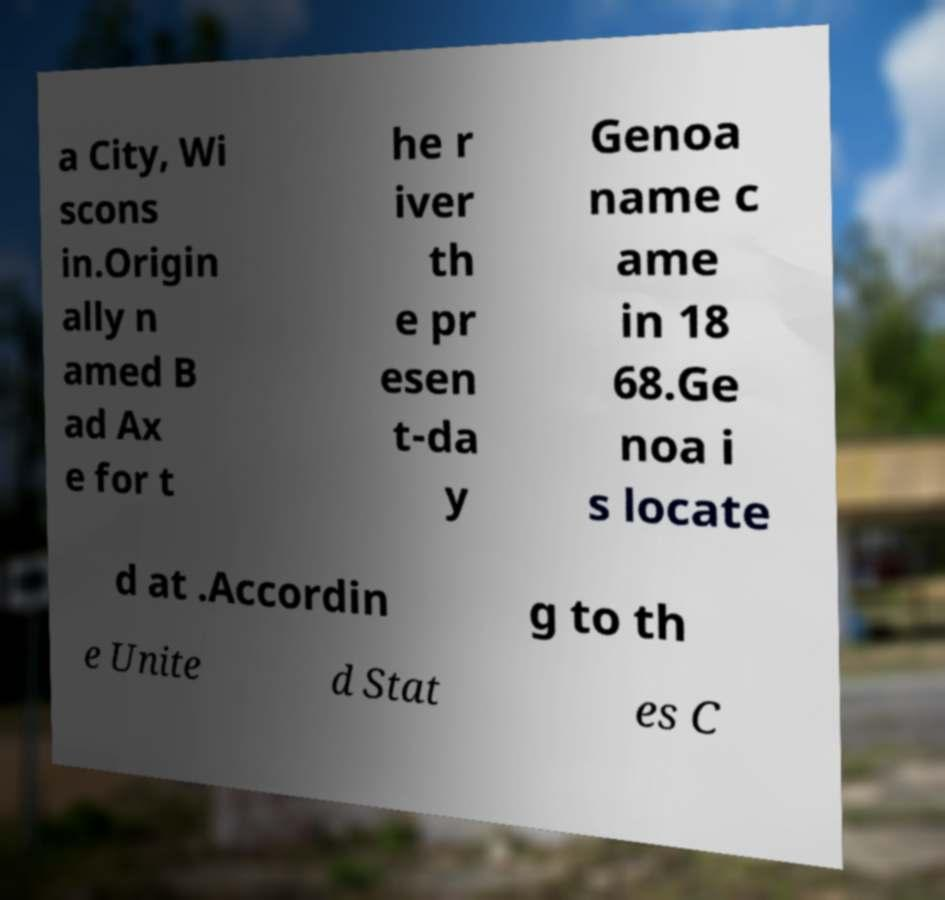Please identify and transcribe the text found in this image. a City, Wi scons in.Origin ally n amed B ad Ax e for t he r iver th e pr esen t-da y Genoa name c ame in 18 68.Ge noa i s locate d at .Accordin g to th e Unite d Stat es C 